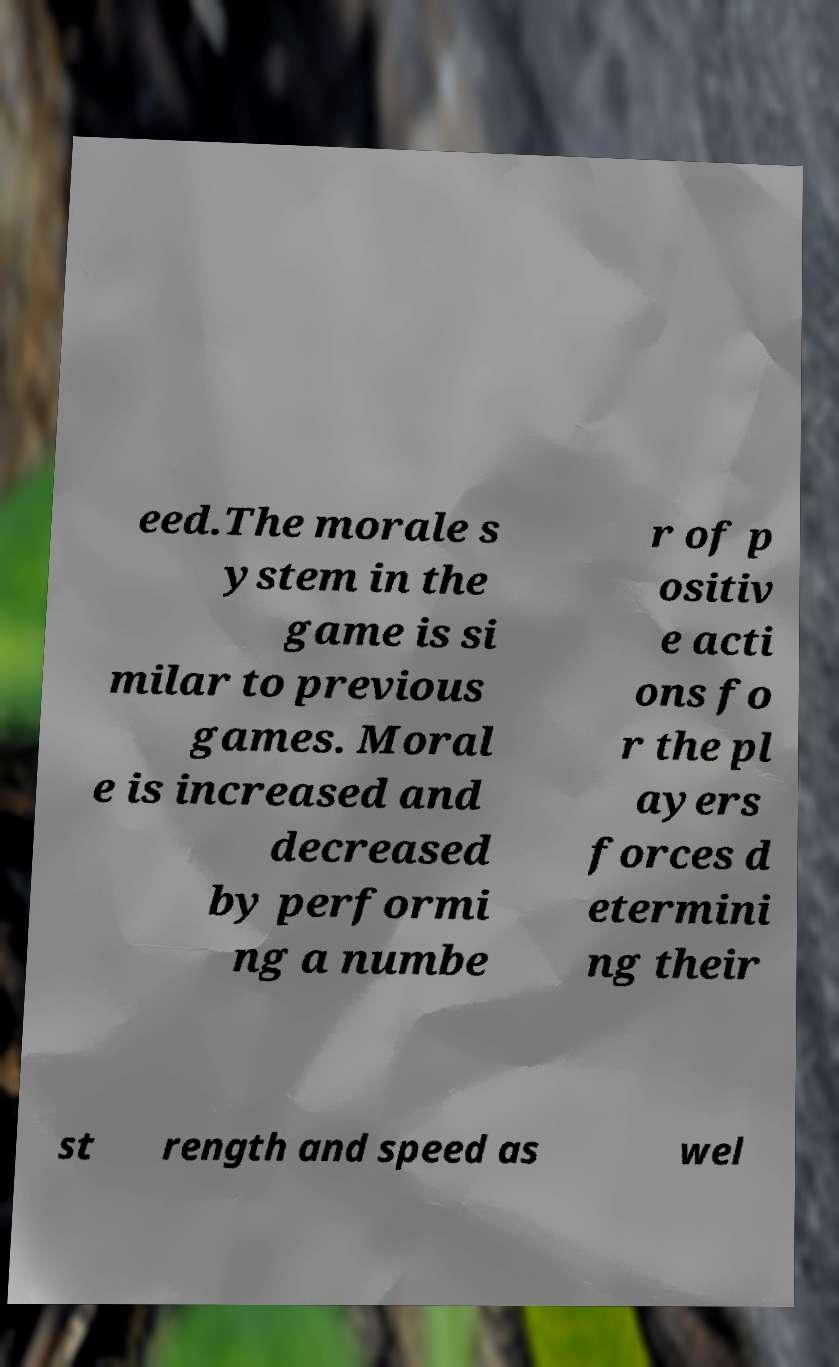I need the written content from this picture converted into text. Can you do that? eed.The morale s ystem in the game is si milar to previous games. Moral e is increased and decreased by performi ng a numbe r of p ositiv e acti ons fo r the pl ayers forces d etermini ng their st rength and speed as wel 